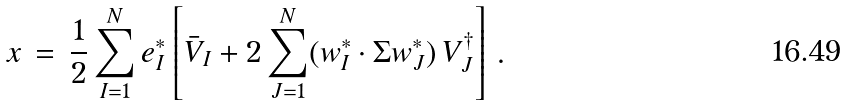<formula> <loc_0><loc_0><loc_500><loc_500>x \, = \, \frac { 1 } { 2 } \sum _ { I = 1 } ^ { N } e _ { I } ^ { * } \left [ \bar { V } _ { I } + 2 \sum _ { J = 1 } ^ { N } ( w _ { I } ^ { * } \cdot \Sigma w ^ { * } _ { J } ) \, V _ { J } ^ { \dagger } \right ] \, .</formula> 